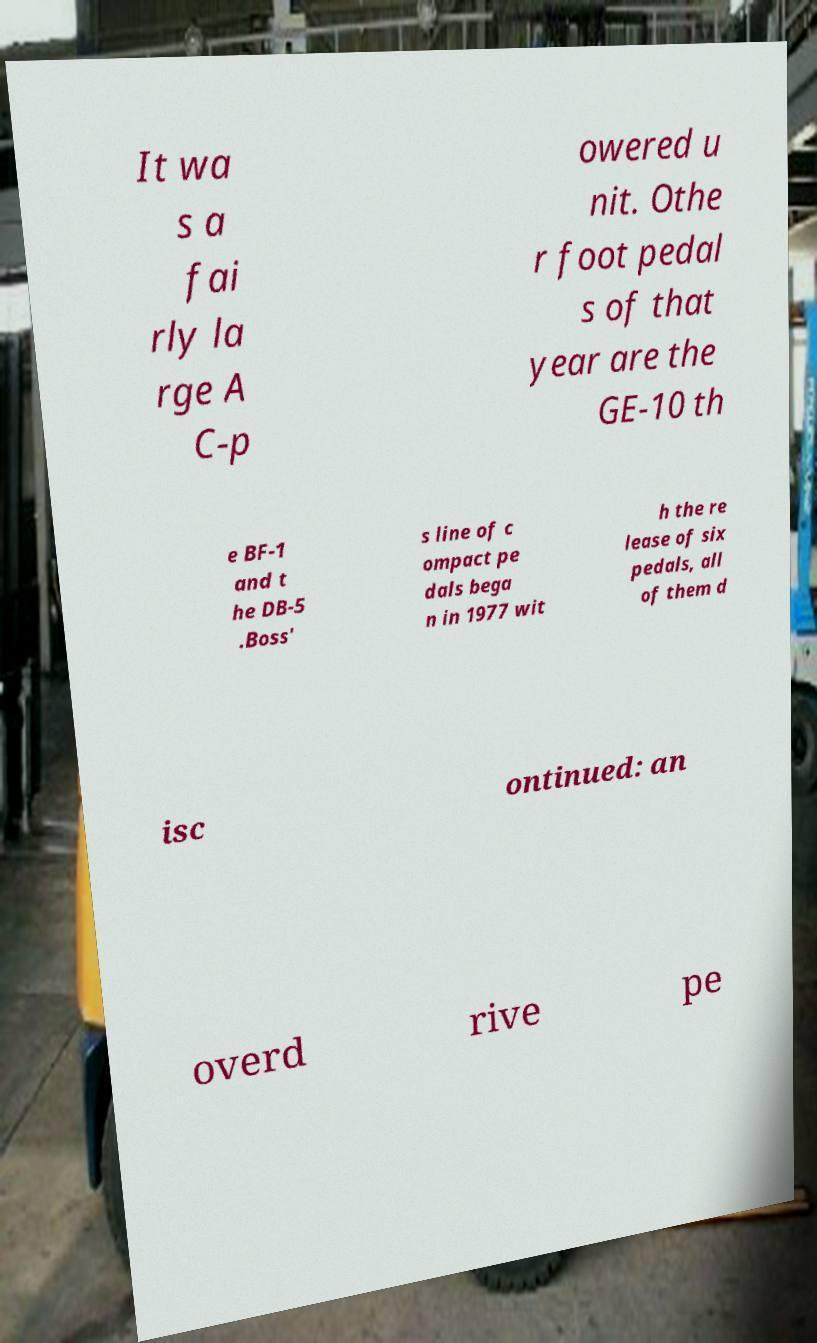For documentation purposes, I need the text within this image transcribed. Could you provide that? It wa s a fai rly la rge A C-p owered u nit. Othe r foot pedal s of that year are the GE-10 th e BF-1 and t he DB-5 .Boss' s line of c ompact pe dals bega n in 1977 wit h the re lease of six pedals, all of them d isc ontinued: an overd rive pe 